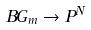<formula> <loc_0><loc_0><loc_500><loc_500>B G _ { m } \rightarrow P ^ { N }</formula> 